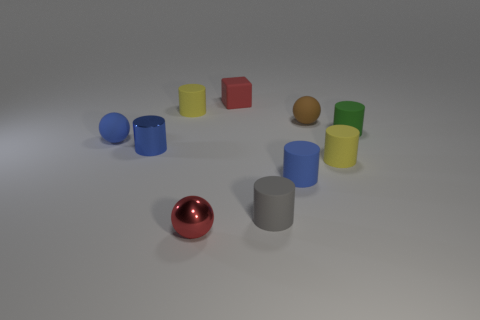Subtract 2 cylinders. How many cylinders are left? 4 Subtract all yellow cylinders. How many cylinders are left? 4 Subtract all gray cylinders. How many cylinders are left? 5 Subtract all cyan cylinders. Subtract all blue blocks. How many cylinders are left? 6 Subtract all cubes. How many objects are left? 9 Subtract 1 red spheres. How many objects are left? 9 Subtract all red objects. Subtract all red spheres. How many objects are left? 7 Add 1 green matte objects. How many green matte objects are left? 2 Add 6 tiny green rubber things. How many tiny green rubber things exist? 7 